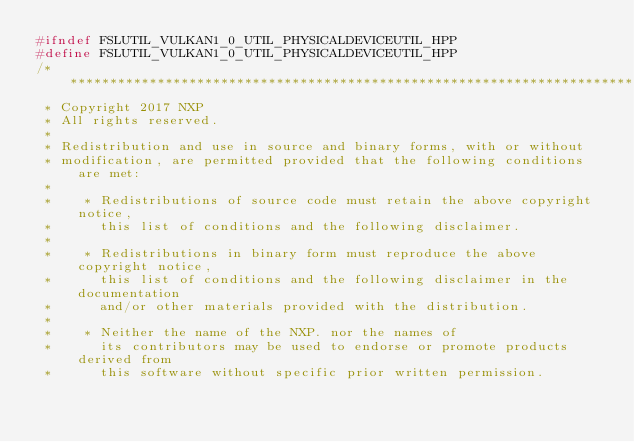Convert code to text. <code><loc_0><loc_0><loc_500><loc_500><_C++_>#ifndef FSLUTIL_VULKAN1_0_UTIL_PHYSICALDEVICEUTIL_HPP
#define FSLUTIL_VULKAN1_0_UTIL_PHYSICALDEVICEUTIL_HPP
/****************************************************************************************************************************************************
 * Copyright 2017 NXP
 * All rights reserved.
 *
 * Redistribution and use in source and binary forms, with or without
 * modification, are permitted provided that the following conditions are met:
 *
 *    * Redistributions of source code must retain the above copyright notice,
 *      this list of conditions and the following disclaimer.
 *
 *    * Redistributions in binary form must reproduce the above copyright notice,
 *      this list of conditions and the following disclaimer in the documentation
 *      and/or other materials provided with the distribution.
 *
 *    * Neither the name of the NXP. nor the names of
 *      its contributors may be used to endorse or promote products derived from
 *      this software without specific prior written permission.</code> 